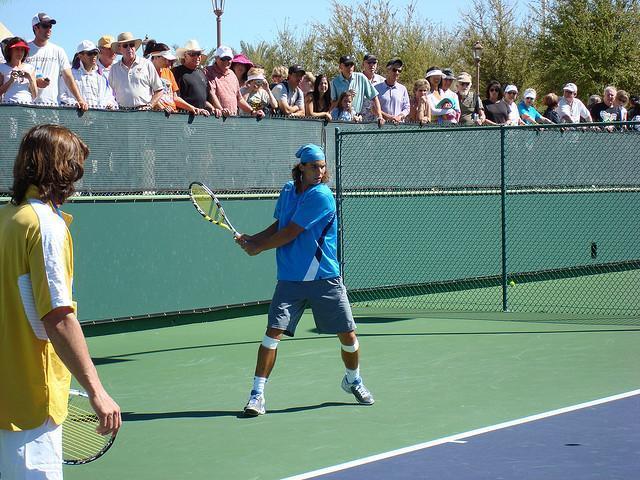How many tennis rackets are in the picture?
Give a very brief answer. 1. How many people can you see?
Give a very brief answer. 6. 